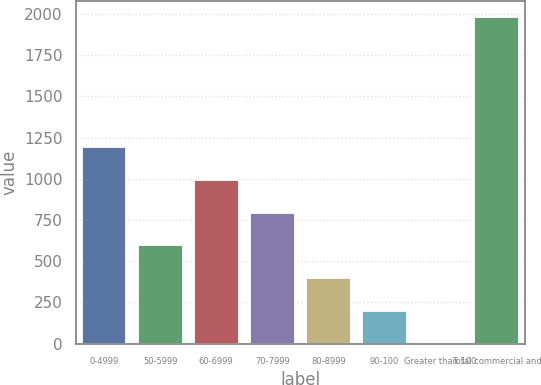Convert chart to OTSL. <chart><loc_0><loc_0><loc_500><loc_500><bar_chart><fcel>0-4999<fcel>50-5999<fcel>60-6999<fcel>70-7999<fcel>80-8999<fcel>90-100<fcel>Greater than 100<fcel>Total commercial and<nl><fcel>1190.16<fcel>595.56<fcel>991.96<fcel>793.76<fcel>397.36<fcel>199.16<fcel>0.96<fcel>1983<nl></chart> 